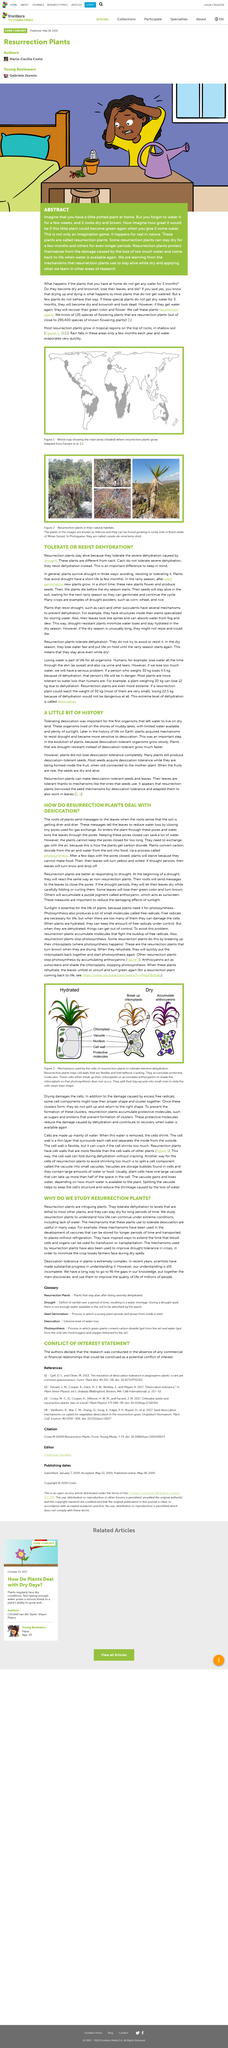Mention a couple of crucial points in this snapshot. Plants that produce desiccation-tolerant seeds are able to survive extreme conditions of dryness and can still germinate and grow into healthy plants even after undergoing the process of desiccation. In general, plants survive drought through avoiding, resisting, or tolerating the water scarcity. The first organisms that left water to live on dry land lived on the shores of muddy lakes. Excessive free radicals can cause alterations in the shape and clustering of cell components, leading to disruption of their normal function. Resurrection plants are types of plants that are capable of making desiccation-tolerant seeds and leaves. 